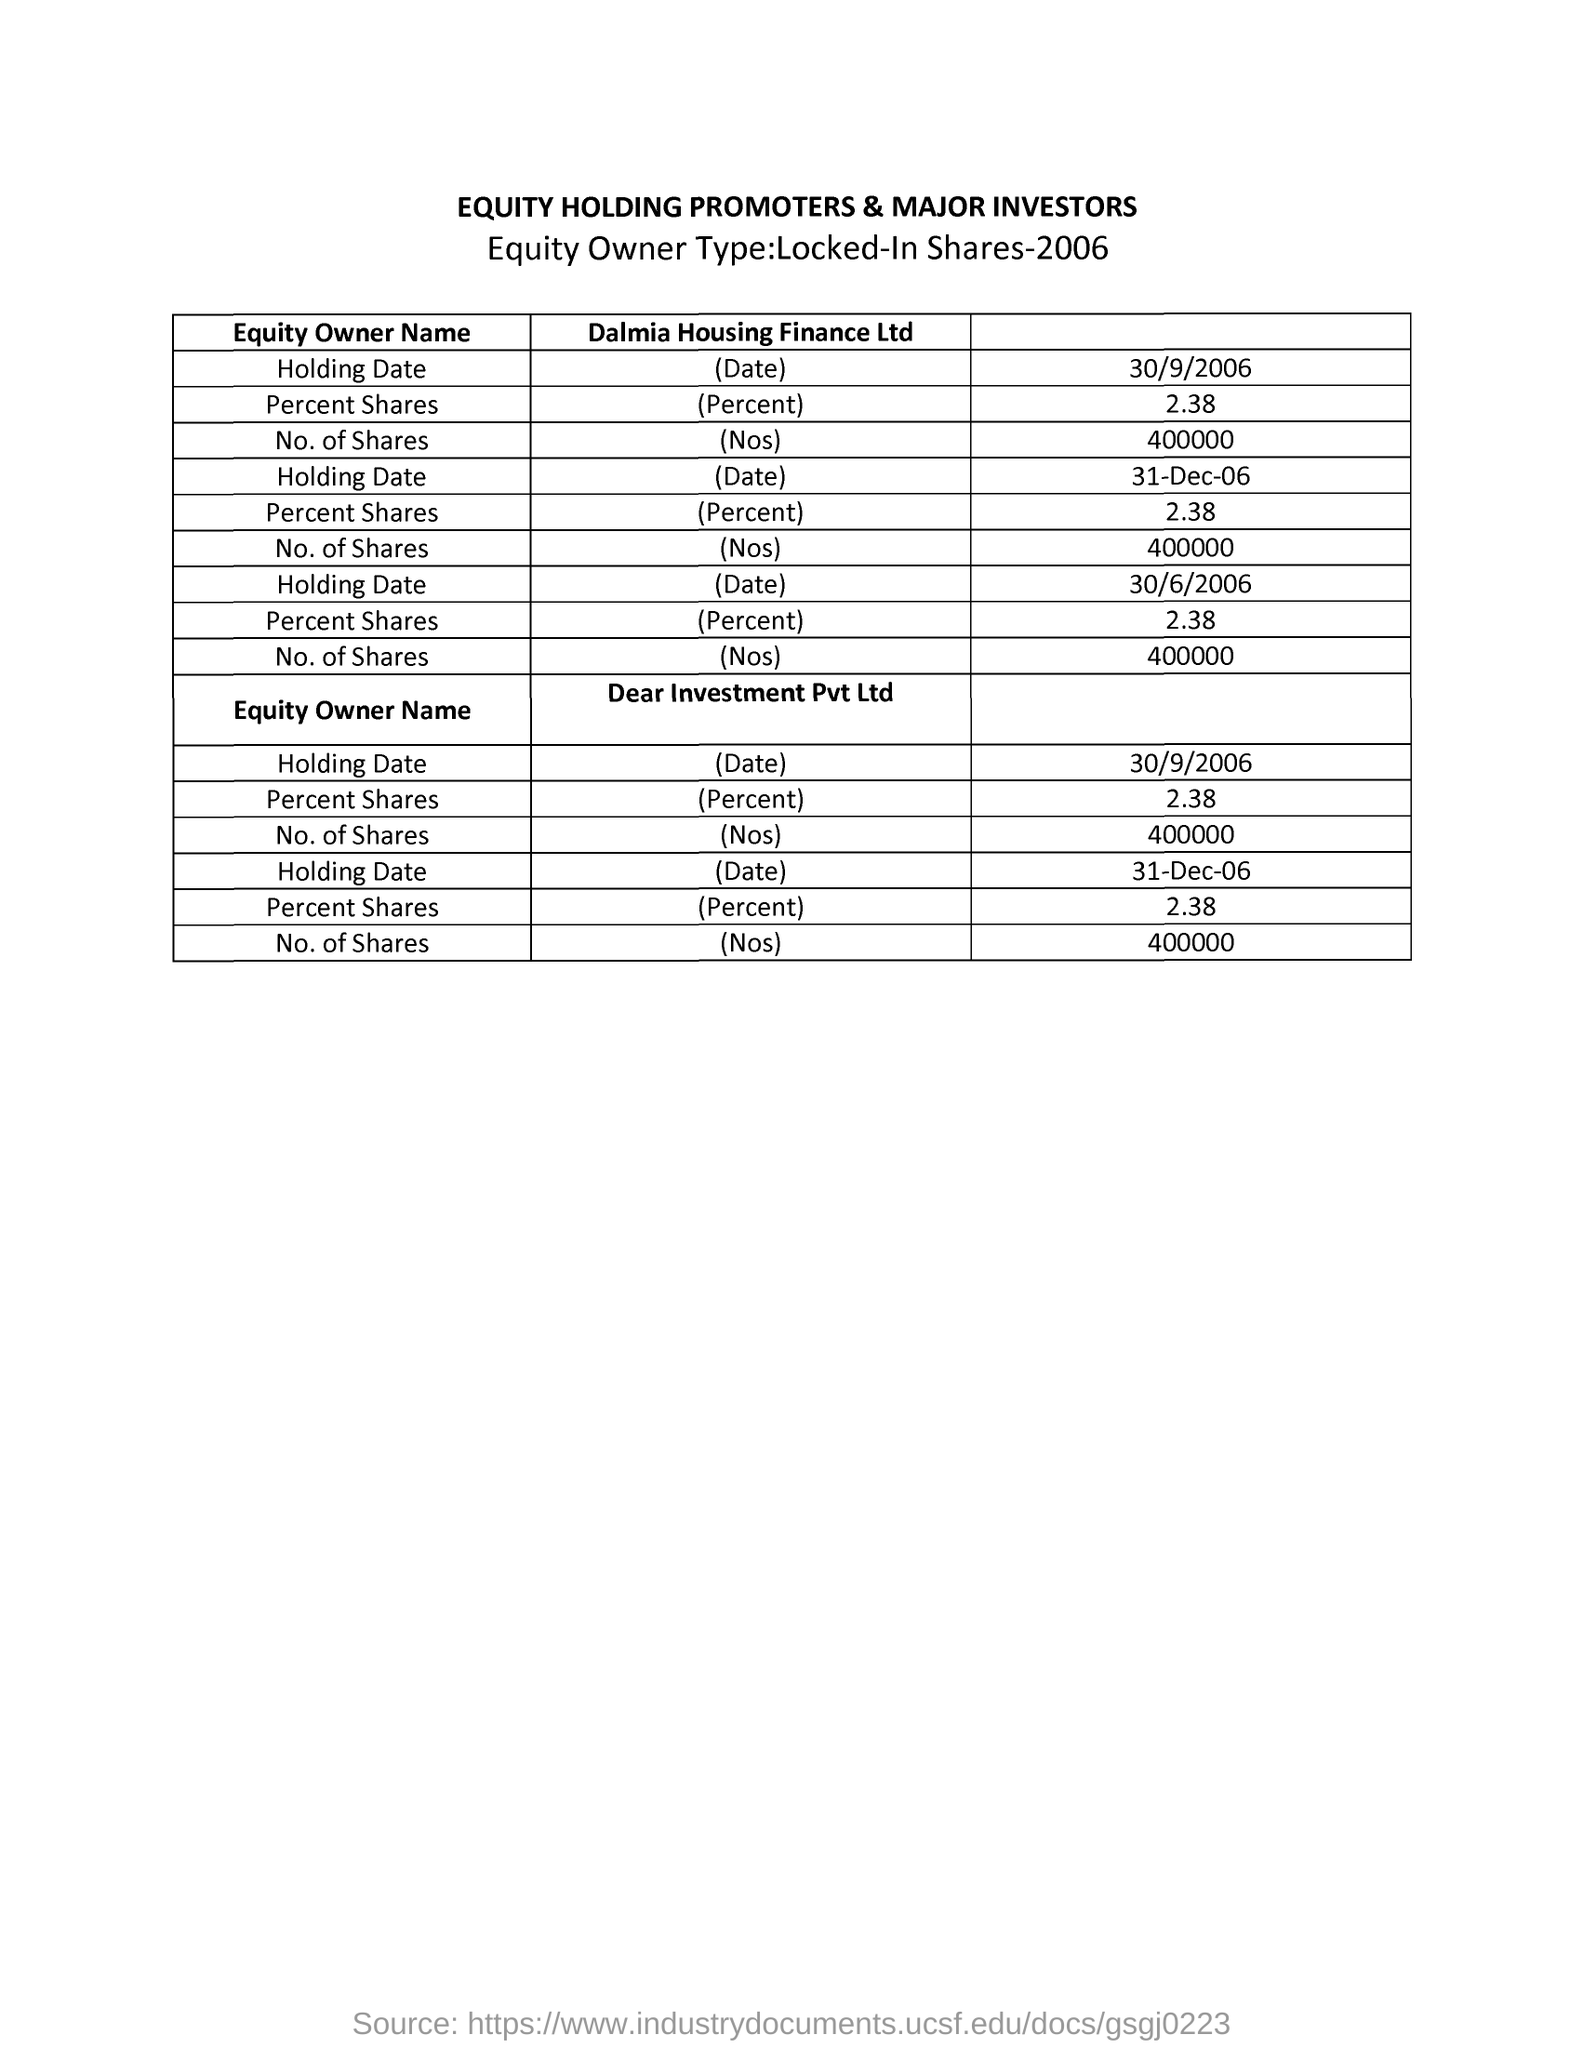How many shares are there for Dalmia Housing Finance Ltd on 30/9/2006?
Give a very brief answer. 400000. 